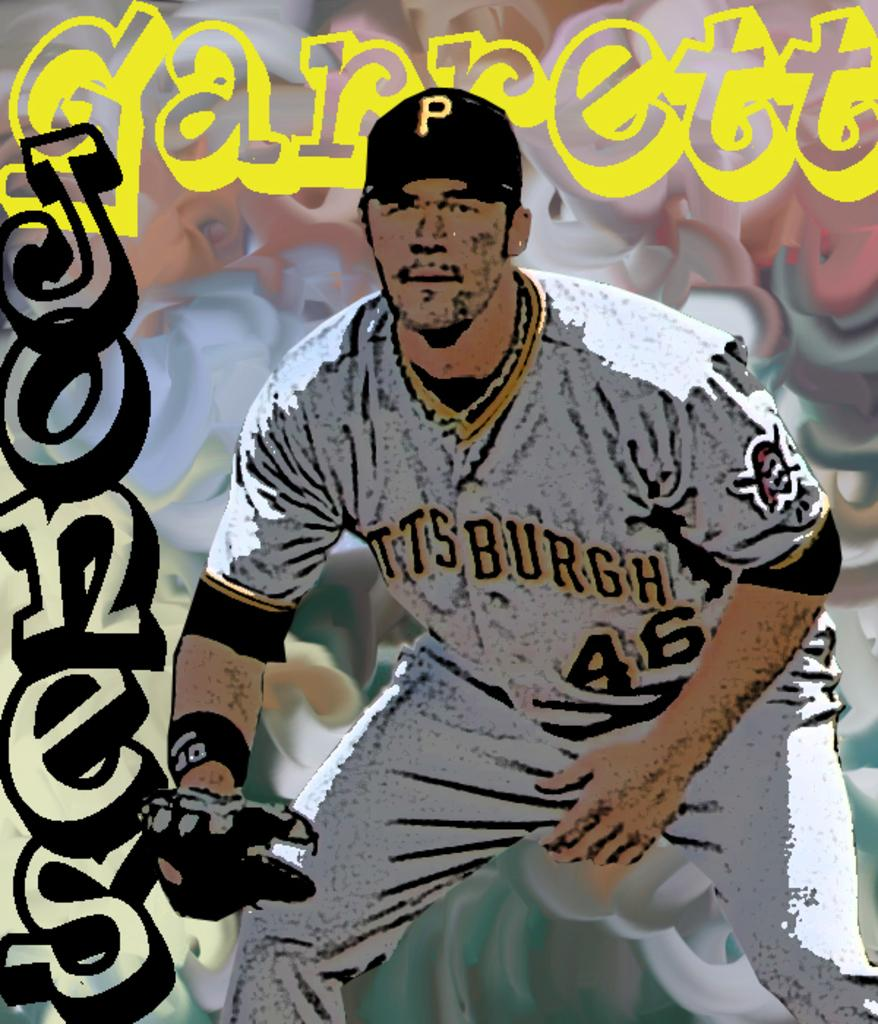<image>
Write a terse but informative summary of the picture. A baseball player is waiting for the ball and his jersey says Pittsburgh. 